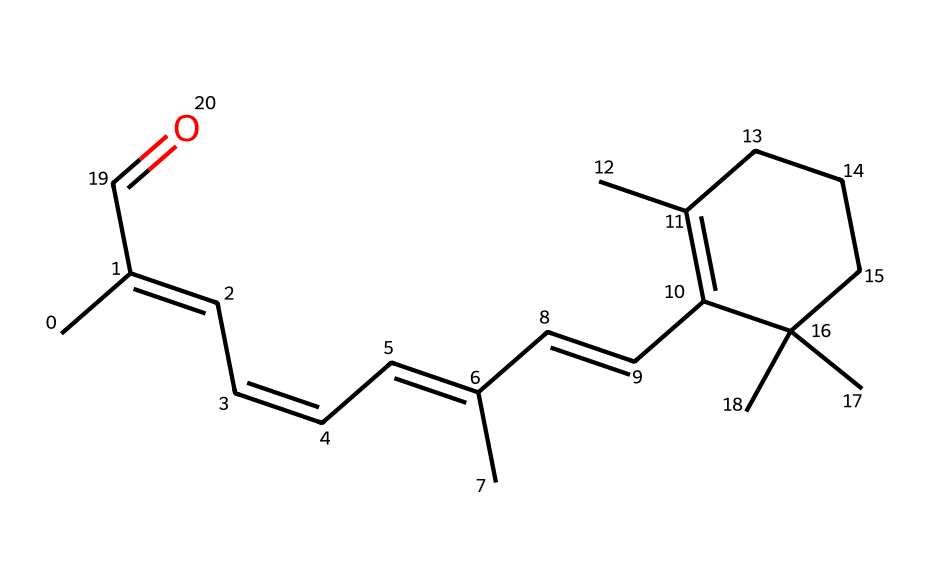What is the common name of this compound? The compound represented by the SMILES is known as retinal, which is a derivative of vitamin A important for vision.
Answer: retinal How many double bonds are present in this molecule? By analyzing the structure, we see there are five double bonds, as indicated by the "C=C" segments in the SMILES notation.
Answer: five What is the functional group present in this molecule? The molecule contains a carbonyl group due to the "C=O" part of the SMILES, indicative of a ketone.
Answer: ketone Are there geometric isomers possible for this compound? Yes, the presence of multiple double bonds in the structure allows for geometric isomerism due to the rigid nature of double bonds, leading to different spatial arrangements.
Answer: yes What is the significance of retinal in eye health? Retinal plays a crucial role in the visual cycle as it is a light-absorbing molecule that converts light into electrical signals within the retina, essential for vision.
Answer: vision How many rings are present in this molecule? Upon examining the structure, there is one cyclohexane ring indicated by the "C1" notation in the SMILES, signifying the start and return of a cyclic structure.
Answer: one What type of isomerism can retinal exhibit? Given the presence of double bonds and different substituents around them, retinal can exhibit geometric isomerism, specifically cis/trans isomerism.
Answer: geometric isomerism 